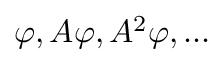Convert formula to latex. <formula><loc_0><loc_0><loc_500><loc_500>\varphi , A \varphi , A ^ { 2 } \varphi , \dots</formula> 